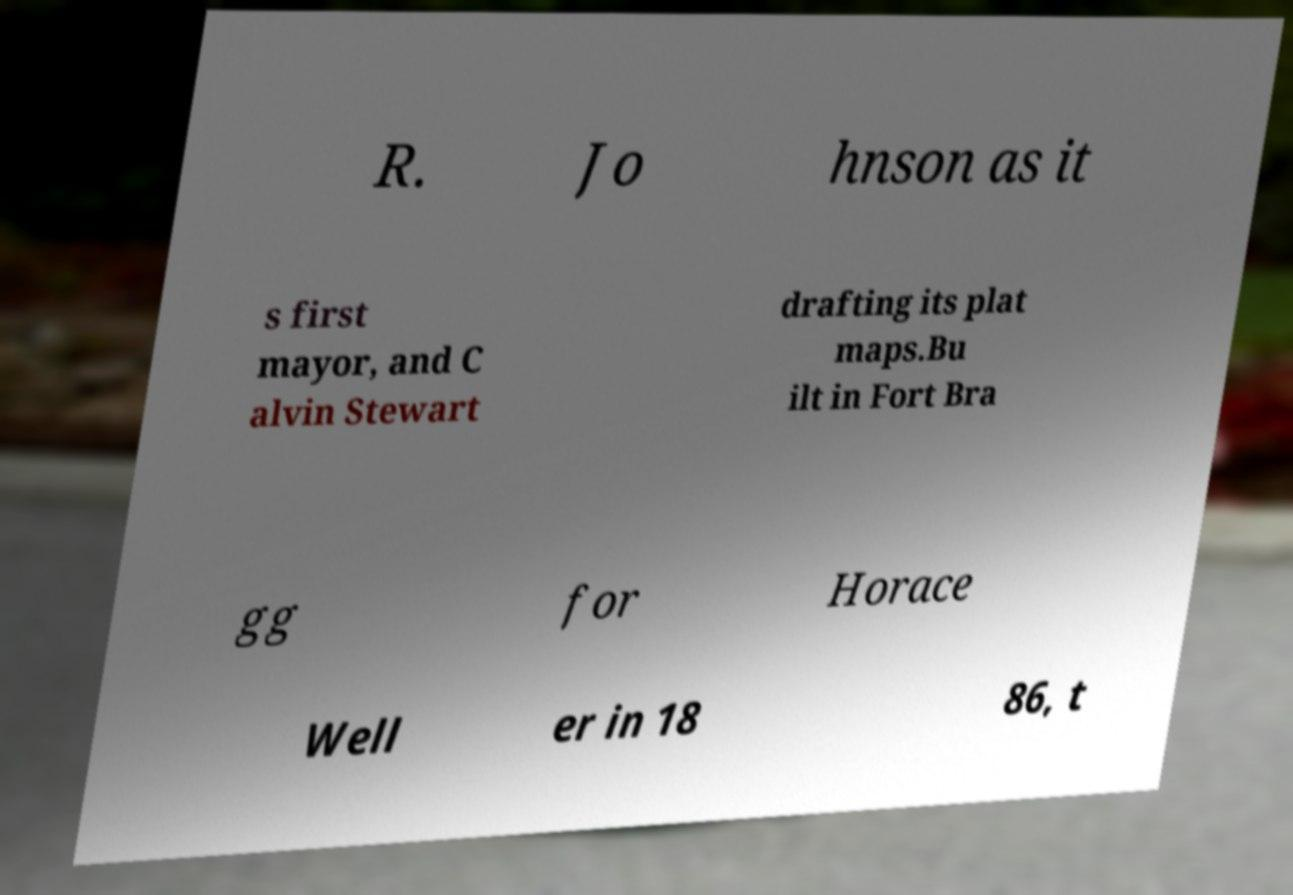What messages or text are displayed in this image? I need them in a readable, typed format. R. Jo hnson as it s first mayor, and C alvin Stewart drafting its plat maps.Bu ilt in Fort Bra gg for Horace Well er in 18 86, t 